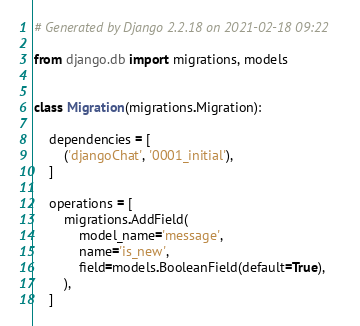Convert code to text. <code><loc_0><loc_0><loc_500><loc_500><_Python_># Generated by Django 2.2.18 on 2021-02-18 09:22

from django.db import migrations, models


class Migration(migrations.Migration):

    dependencies = [
        ('djangoChat', '0001_initial'),
    ]

    operations = [
        migrations.AddField(
            model_name='message',
            name='is_new',
            field=models.BooleanField(default=True),
        ),
    ]
</code> 